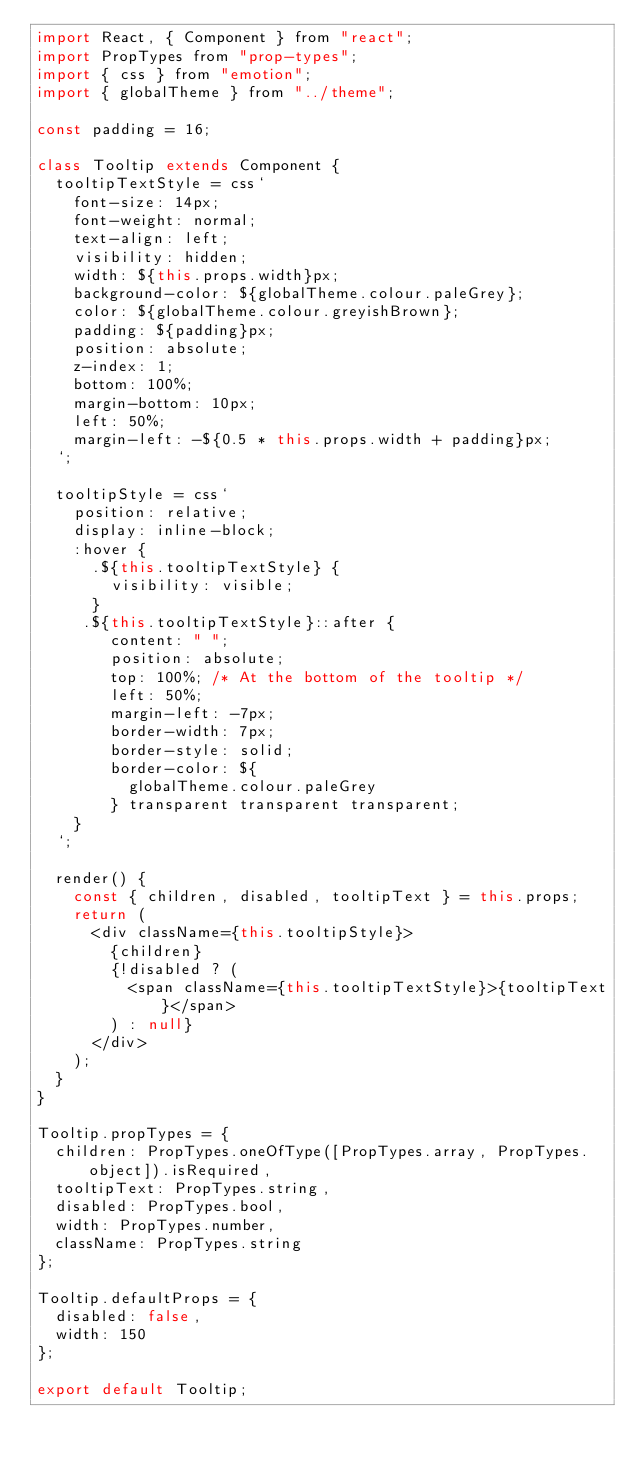<code> <loc_0><loc_0><loc_500><loc_500><_JavaScript_>import React, { Component } from "react";
import PropTypes from "prop-types";
import { css } from "emotion";
import { globalTheme } from "../theme";

const padding = 16;

class Tooltip extends Component {
  tooltipTextStyle = css`
    font-size: 14px;
    font-weight: normal;
    text-align: left;
    visibility: hidden;
    width: ${this.props.width}px;
    background-color: ${globalTheme.colour.paleGrey};
    color: ${globalTheme.colour.greyishBrown};
    padding: ${padding}px;
    position: absolute;
    z-index: 1;
    bottom: 100%;
    margin-bottom: 10px;
    left: 50%;
    margin-left: -${0.5 * this.props.width + padding}px;
  `;

  tooltipStyle = css`
    position: relative;
    display: inline-block;
    :hover {
      .${this.tooltipTextStyle} {
        visibility: visible;
      }
     .${this.tooltipTextStyle}::after {
        content: " ";
        position: absolute;
        top: 100%; /* At the bottom of the tooltip */
        left: 50%;
        margin-left: -7px;
        border-width: 7px;
        border-style: solid;
        border-color: ${
          globalTheme.colour.paleGrey
        } transparent transparent transparent;
    }
  `;

  render() {
    const { children, disabled, tooltipText } = this.props;
    return (
      <div className={this.tooltipStyle}>
        {children}
        {!disabled ? (
          <span className={this.tooltipTextStyle}>{tooltipText}</span>
        ) : null}
      </div>
    );
  }
}

Tooltip.propTypes = {
  children: PropTypes.oneOfType([PropTypes.array, PropTypes.object]).isRequired,
  tooltipText: PropTypes.string,
  disabled: PropTypes.bool,
  width: PropTypes.number,
  className: PropTypes.string
};

Tooltip.defaultProps = {
  disabled: false,
  width: 150
};

export default Tooltip;
</code> 